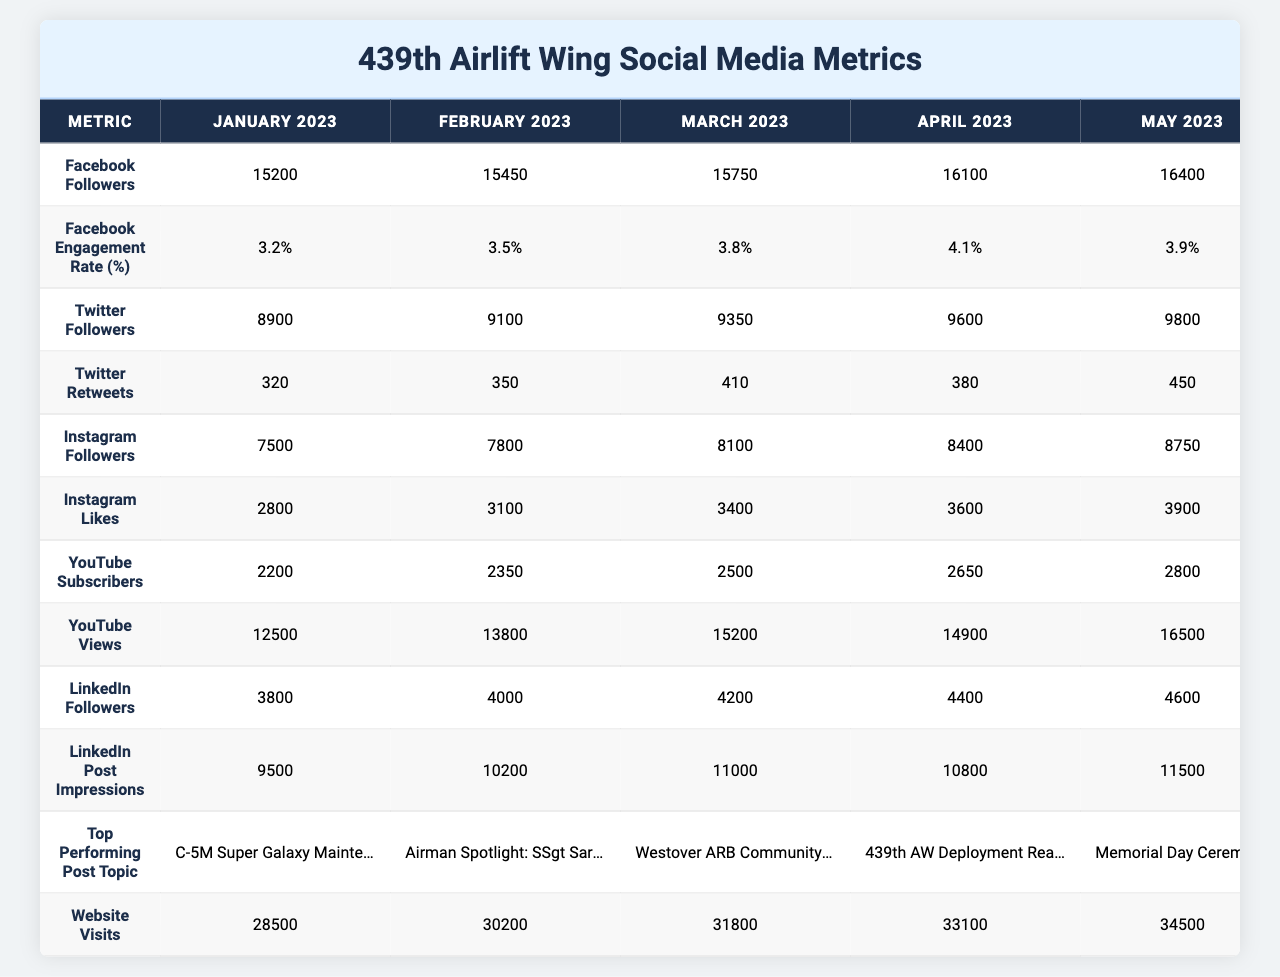What were the Facebook followers in May 2023? Referring to the table, the number of Facebook followers listed under May 2023 is 16,400.
Answer: 16,400 What is the engagement rate on Facebook for April 2023? The engagement rate for Facebook in April 2023 can be found directly in the "Facebook Engagement Rate" row under April 2023, which is 4.1%.
Answer: 4.1% How many Twitter retweets were recorded in March 2023? Checking the "Twitter Retweets" row for March 2023 shows there were 410 retweets.
Answer: 410 What was the increase in Instagram followers from January to June 2023? The number of Instagram followers in January 2023 was 7,500 and in June 2023 it was 9,100. The increase is calculated as 9,100 - 7,500 = 1,600.
Answer: 1,600 Which month had the highest number of YouTube subscribers? The YouTube subscriber counts for each month are: January (2,200), February (2,350), March (2,500), April (2,650), May (2,800), and June (3,000). The highest number, 3,000, occurred in June 2023.
Answer: June 2023 What is the total number of website visits from January to June 2023? The website visits are as follows: January 28,500, February 30,200, March 31,800, April 33,100, May 34,500, and June 36,000. The total is calculated as 28,500 + 30,200 + 31,800 + 33,100 + 34,500 + 36,000 =  224,100.
Answer: 224,100 Did the Facebook engagement rate decrease from April to May 2023? In April 2023, the engagement rate was 4.1%, and in May 2023, it was 3.9%. Since 4.1% > 3.9%, the engagement rate did indeed decrease.
Answer: Yes Which social media platform had the largest follower increase between June 2023 and January 2023? Comparing the changes in follower counts: Facebook increased by 1,550 (from 15,200 to 16,750), Twitter by 1,150 (from 8,900 to 10,050), Instagram by 1,600 (from 7,500 to 9,100), YouTube by 800 (from 2,200 to 3,000), and LinkedIn by 1,050 (from 3,800 to 4,850). Instagram had the largest increase of 1,600 followers.
Answer: Instagram What is the overall average of Twitter retweets over the six months? The retweet counts for each month are: 320, 350, 410, 380, 450, and 490. The sum is 2,400 (320 + 350 + 410 + 380 + 450 + 490), and the average is 2,400 divided by 6, which equals 400.
Answer: 400 What was the highest number of LinkedIn post impressions in 2023? Referring to the "LinkedIn Post Impressions" row, the highest number recorded is 12,300 in June 2023.
Answer: 12,300 